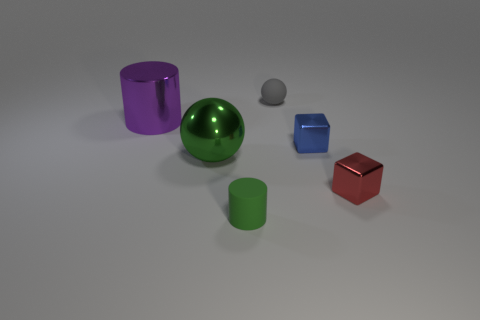Add 1 large green metal objects. How many objects exist? 7 Subtract all cubes. How many objects are left? 4 Add 5 blue things. How many blue things are left? 6 Add 2 small green rubber cylinders. How many small green rubber cylinders exist? 3 Subtract 0 yellow spheres. How many objects are left? 6 Subtract all large balls. Subtract all small red objects. How many objects are left? 4 